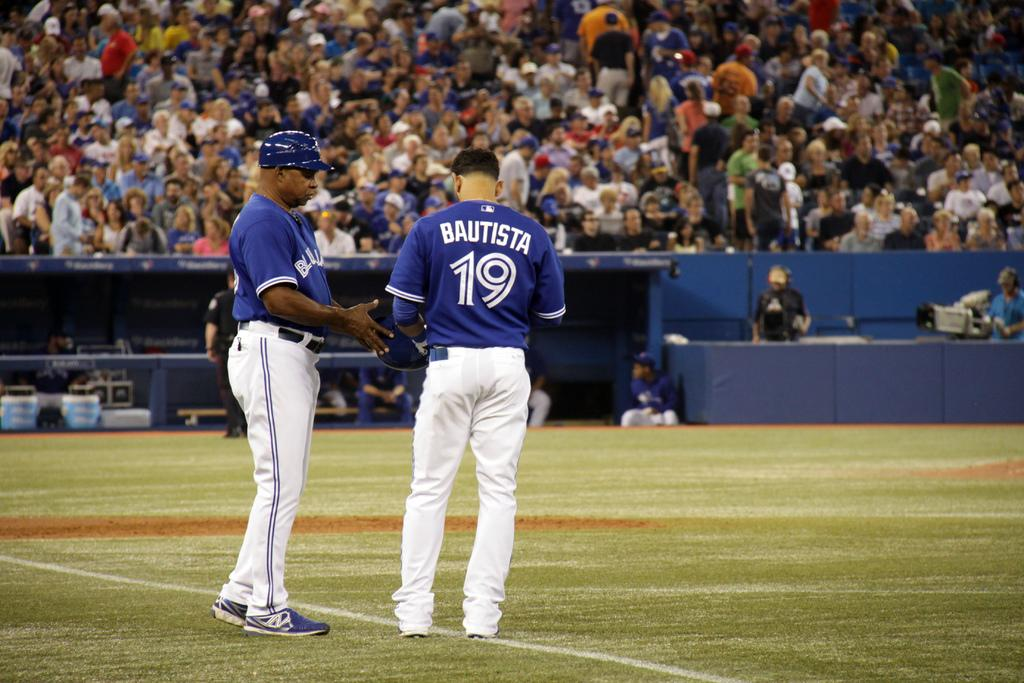<image>
Give a short and clear explanation of the subsequent image. Two baseball players wearing blue and one called Bautista and wearing the number 19 talk on the park in front of a large crowd. 